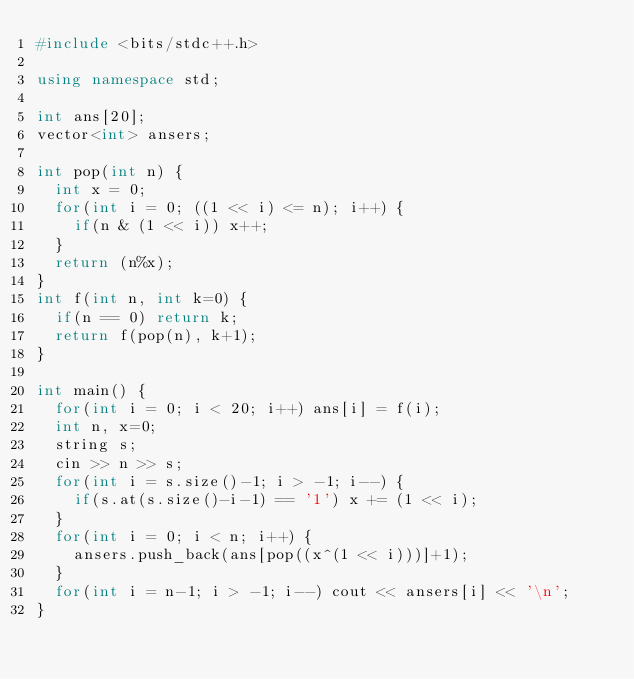<code> <loc_0><loc_0><loc_500><loc_500><_C++_>#include <bits/stdc++.h>

using namespace std;

int ans[20];
vector<int> ansers;

int pop(int n) {
	int x = 0;
	for(int i = 0; ((1 << i) <= n); i++) {
		if(n & (1 << i)) x++;
	}
	return (n%x);
}
int f(int n, int k=0) {
	if(n == 0) return k;
	return f(pop(n), k+1);
}

int main() {
	for(int i = 0; i < 20; i++) ans[i] = f(i);
	int n, x=0;
	string s;
	cin >> n >> s;
	for(int i = s.size()-1; i > -1; i--) {
		if(s.at(s.size()-i-1) == '1') x += (1 << i);
	}
	for(int i = 0; i < n; i++) {
		ansers.push_back(ans[pop((x^(1 << i)))]+1);
	}
	for(int i = n-1; i > -1; i--) cout << ansers[i] << '\n';
}</code> 